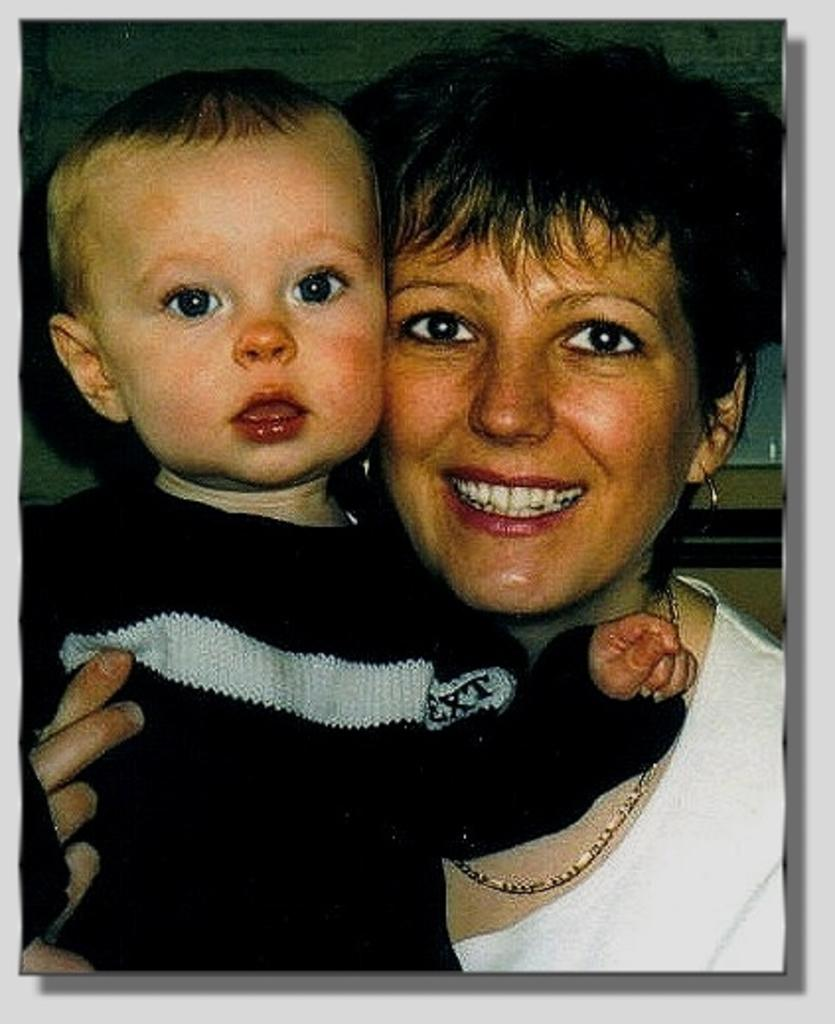What is the expression of the woman in the image? The woman in the image has a smiling expression. Who else is present in the image besides the woman? There is a boy in the image. Can you describe any visual elements of the image? The image has borders. What type of glue is being used to hold the boy's face together in the image? There is no indication in the image that the boy's face is being held together with glue, nor is there any glue visible in the image. 